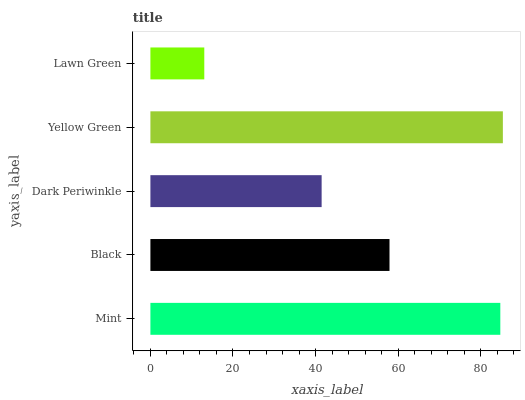Is Lawn Green the minimum?
Answer yes or no. Yes. Is Yellow Green the maximum?
Answer yes or no. Yes. Is Black the minimum?
Answer yes or no. No. Is Black the maximum?
Answer yes or no. No. Is Mint greater than Black?
Answer yes or no. Yes. Is Black less than Mint?
Answer yes or no. Yes. Is Black greater than Mint?
Answer yes or no. No. Is Mint less than Black?
Answer yes or no. No. Is Black the high median?
Answer yes or no. Yes. Is Black the low median?
Answer yes or no. Yes. Is Yellow Green the high median?
Answer yes or no. No. Is Lawn Green the low median?
Answer yes or no. No. 